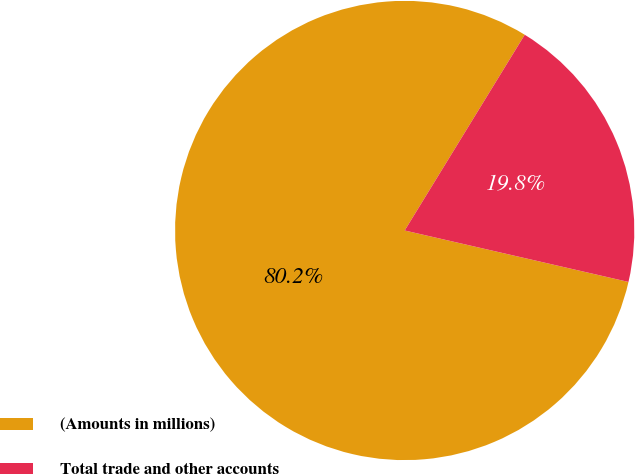Convert chart to OTSL. <chart><loc_0><loc_0><loc_500><loc_500><pie_chart><fcel>(Amounts in millions)<fcel>Total trade and other accounts<nl><fcel>80.16%<fcel>19.84%<nl></chart> 